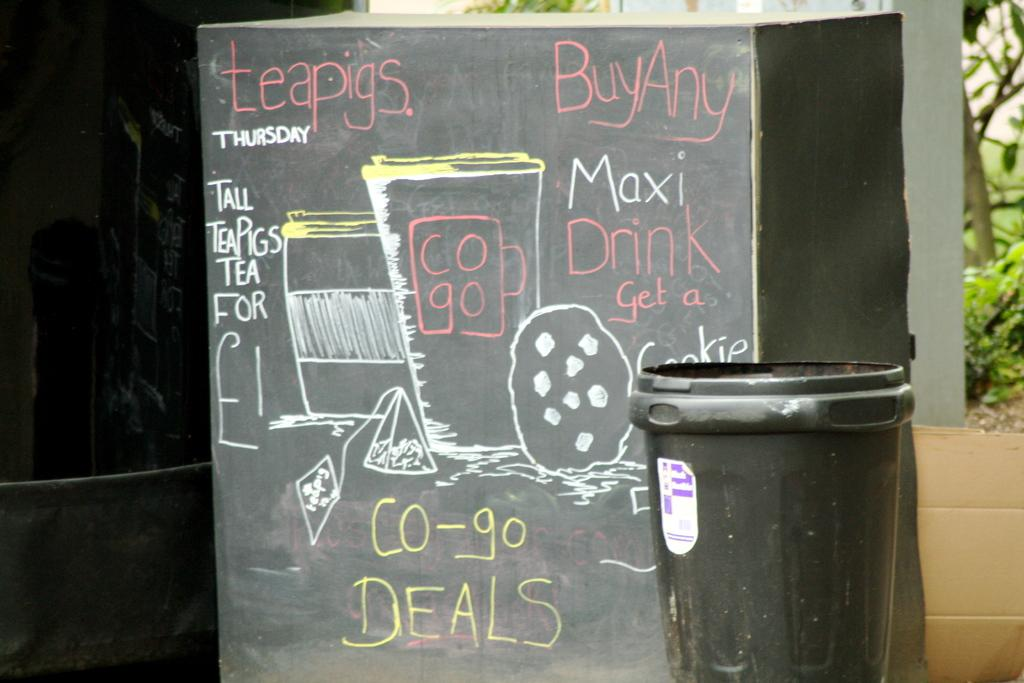Provide a one-sentence caption for the provided image. A sign written in pink, white and yellow chalk advertising co-go deals. 